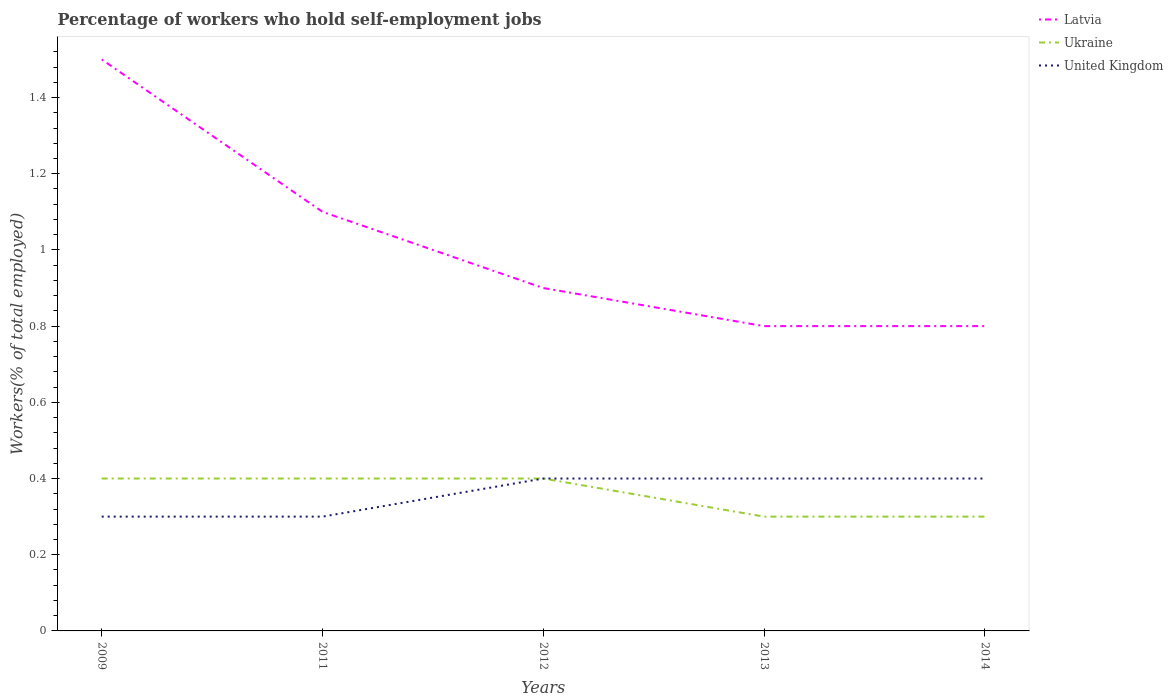How many different coloured lines are there?
Give a very brief answer. 3. Does the line corresponding to Latvia intersect with the line corresponding to Ukraine?
Make the answer very short. No. Is the number of lines equal to the number of legend labels?
Your answer should be very brief. Yes. Across all years, what is the maximum percentage of self-employed workers in United Kingdom?
Offer a very short reply. 0.3. In which year was the percentage of self-employed workers in United Kingdom maximum?
Offer a very short reply. 2009. What is the total percentage of self-employed workers in Ukraine in the graph?
Provide a succinct answer. 0. What is the difference between the highest and the second highest percentage of self-employed workers in Ukraine?
Ensure brevity in your answer.  0.1. Is the percentage of self-employed workers in United Kingdom strictly greater than the percentage of self-employed workers in Ukraine over the years?
Provide a short and direct response. No. How many lines are there?
Your answer should be compact. 3. Does the graph contain any zero values?
Your answer should be very brief. No. How many legend labels are there?
Your answer should be compact. 3. What is the title of the graph?
Offer a terse response. Percentage of workers who hold self-employment jobs. Does "Belarus" appear as one of the legend labels in the graph?
Make the answer very short. No. What is the label or title of the X-axis?
Give a very brief answer. Years. What is the label or title of the Y-axis?
Keep it short and to the point. Workers(% of total employed). What is the Workers(% of total employed) of Latvia in 2009?
Your answer should be compact. 1.5. What is the Workers(% of total employed) of Ukraine in 2009?
Provide a short and direct response. 0.4. What is the Workers(% of total employed) in United Kingdom in 2009?
Your response must be concise. 0.3. What is the Workers(% of total employed) in Latvia in 2011?
Offer a terse response. 1.1. What is the Workers(% of total employed) of Ukraine in 2011?
Offer a very short reply. 0.4. What is the Workers(% of total employed) of United Kingdom in 2011?
Give a very brief answer. 0.3. What is the Workers(% of total employed) in Latvia in 2012?
Offer a very short reply. 0.9. What is the Workers(% of total employed) of Ukraine in 2012?
Your answer should be compact. 0.4. What is the Workers(% of total employed) in United Kingdom in 2012?
Ensure brevity in your answer.  0.4. What is the Workers(% of total employed) in Latvia in 2013?
Your response must be concise. 0.8. What is the Workers(% of total employed) of Ukraine in 2013?
Provide a short and direct response. 0.3. What is the Workers(% of total employed) of United Kingdom in 2013?
Make the answer very short. 0.4. What is the Workers(% of total employed) of Latvia in 2014?
Offer a terse response. 0.8. What is the Workers(% of total employed) of Ukraine in 2014?
Make the answer very short. 0.3. What is the Workers(% of total employed) of United Kingdom in 2014?
Your answer should be very brief. 0.4. Across all years, what is the maximum Workers(% of total employed) in Ukraine?
Ensure brevity in your answer.  0.4. Across all years, what is the maximum Workers(% of total employed) of United Kingdom?
Provide a succinct answer. 0.4. Across all years, what is the minimum Workers(% of total employed) in Latvia?
Make the answer very short. 0.8. Across all years, what is the minimum Workers(% of total employed) in Ukraine?
Provide a succinct answer. 0.3. Across all years, what is the minimum Workers(% of total employed) of United Kingdom?
Give a very brief answer. 0.3. What is the total Workers(% of total employed) in Ukraine in the graph?
Your answer should be compact. 1.8. What is the difference between the Workers(% of total employed) of Latvia in 2009 and that in 2011?
Ensure brevity in your answer.  0.4. What is the difference between the Workers(% of total employed) in Latvia in 2009 and that in 2012?
Provide a short and direct response. 0.6. What is the difference between the Workers(% of total employed) of United Kingdom in 2009 and that in 2012?
Offer a terse response. -0.1. What is the difference between the Workers(% of total employed) of Latvia in 2011 and that in 2012?
Make the answer very short. 0.2. What is the difference between the Workers(% of total employed) of Ukraine in 2011 and that in 2012?
Provide a short and direct response. 0. What is the difference between the Workers(% of total employed) of United Kingdom in 2011 and that in 2012?
Ensure brevity in your answer.  -0.1. What is the difference between the Workers(% of total employed) of Ukraine in 2011 and that in 2013?
Your response must be concise. 0.1. What is the difference between the Workers(% of total employed) in United Kingdom in 2011 and that in 2014?
Your answer should be very brief. -0.1. What is the difference between the Workers(% of total employed) in Latvia in 2012 and that in 2013?
Ensure brevity in your answer.  0.1. What is the difference between the Workers(% of total employed) in Ukraine in 2012 and that in 2013?
Provide a short and direct response. 0.1. What is the difference between the Workers(% of total employed) of Latvia in 2012 and that in 2014?
Ensure brevity in your answer.  0.1. What is the difference between the Workers(% of total employed) of Ukraine in 2012 and that in 2014?
Provide a short and direct response. 0.1. What is the difference between the Workers(% of total employed) of Latvia in 2009 and the Workers(% of total employed) of Ukraine in 2011?
Your answer should be very brief. 1.1. What is the difference between the Workers(% of total employed) in Latvia in 2009 and the Workers(% of total employed) in Ukraine in 2012?
Your answer should be compact. 1.1. What is the difference between the Workers(% of total employed) of Latvia in 2009 and the Workers(% of total employed) of United Kingdom in 2012?
Offer a terse response. 1.1. What is the difference between the Workers(% of total employed) in Latvia in 2009 and the Workers(% of total employed) in Ukraine in 2013?
Keep it short and to the point. 1.2. What is the difference between the Workers(% of total employed) in Ukraine in 2009 and the Workers(% of total employed) in United Kingdom in 2013?
Ensure brevity in your answer.  0. What is the difference between the Workers(% of total employed) in Latvia in 2009 and the Workers(% of total employed) in Ukraine in 2014?
Provide a succinct answer. 1.2. What is the difference between the Workers(% of total employed) of Latvia in 2009 and the Workers(% of total employed) of United Kingdom in 2014?
Offer a very short reply. 1.1. What is the difference between the Workers(% of total employed) of Latvia in 2011 and the Workers(% of total employed) of Ukraine in 2012?
Your response must be concise. 0.7. What is the difference between the Workers(% of total employed) of Latvia in 2011 and the Workers(% of total employed) of United Kingdom in 2012?
Make the answer very short. 0.7. What is the difference between the Workers(% of total employed) in Ukraine in 2011 and the Workers(% of total employed) in United Kingdom in 2012?
Your answer should be very brief. 0. What is the difference between the Workers(% of total employed) in Latvia in 2011 and the Workers(% of total employed) in Ukraine in 2013?
Ensure brevity in your answer.  0.8. What is the difference between the Workers(% of total employed) of Ukraine in 2011 and the Workers(% of total employed) of United Kingdom in 2013?
Your answer should be very brief. 0. What is the difference between the Workers(% of total employed) in Latvia in 2011 and the Workers(% of total employed) in Ukraine in 2014?
Make the answer very short. 0.8. What is the difference between the Workers(% of total employed) in Latvia in 2011 and the Workers(% of total employed) in United Kingdom in 2014?
Provide a short and direct response. 0.7. What is the difference between the Workers(% of total employed) in Ukraine in 2011 and the Workers(% of total employed) in United Kingdom in 2014?
Your answer should be compact. 0. What is the difference between the Workers(% of total employed) in Ukraine in 2012 and the Workers(% of total employed) in United Kingdom in 2013?
Give a very brief answer. 0. What is the difference between the Workers(% of total employed) in Latvia in 2012 and the Workers(% of total employed) in United Kingdom in 2014?
Your response must be concise. 0.5. What is the difference between the Workers(% of total employed) in Latvia in 2013 and the Workers(% of total employed) in United Kingdom in 2014?
Make the answer very short. 0.4. What is the average Workers(% of total employed) in Ukraine per year?
Your answer should be compact. 0.36. What is the average Workers(% of total employed) of United Kingdom per year?
Your response must be concise. 0.36. In the year 2009, what is the difference between the Workers(% of total employed) of Latvia and Workers(% of total employed) of United Kingdom?
Keep it short and to the point. 1.2. In the year 2009, what is the difference between the Workers(% of total employed) of Ukraine and Workers(% of total employed) of United Kingdom?
Keep it short and to the point. 0.1. In the year 2011, what is the difference between the Workers(% of total employed) in Latvia and Workers(% of total employed) in Ukraine?
Your answer should be compact. 0.7. In the year 2011, what is the difference between the Workers(% of total employed) in Ukraine and Workers(% of total employed) in United Kingdom?
Your answer should be compact. 0.1. In the year 2012, what is the difference between the Workers(% of total employed) in Latvia and Workers(% of total employed) in Ukraine?
Ensure brevity in your answer.  0.5. In the year 2013, what is the difference between the Workers(% of total employed) in Latvia and Workers(% of total employed) in Ukraine?
Give a very brief answer. 0.5. In the year 2013, what is the difference between the Workers(% of total employed) of Latvia and Workers(% of total employed) of United Kingdom?
Your response must be concise. 0.4. In the year 2013, what is the difference between the Workers(% of total employed) of Ukraine and Workers(% of total employed) of United Kingdom?
Offer a terse response. -0.1. In the year 2014, what is the difference between the Workers(% of total employed) of Latvia and Workers(% of total employed) of Ukraine?
Offer a terse response. 0.5. In the year 2014, what is the difference between the Workers(% of total employed) of Ukraine and Workers(% of total employed) of United Kingdom?
Keep it short and to the point. -0.1. What is the ratio of the Workers(% of total employed) in Latvia in 2009 to that in 2011?
Your answer should be very brief. 1.36. What is the ratio of the Workers(% of total employed) of Ukraine in 2009 to that in 2011?
Ensure brevity in your answer.  1. What is the ratio of the Workers(% of total employed) of Ukraine in 2009 to that in 2012?
Make the answer very short. 1. What is the ratio of the Workers(% of total employed) of Latvia in 2009 to that in 2013?
Keep it short and to the point. 1.88. What is the ratio of the Workers(% of total employed) in United Kingdom in 2009 to that in 2013?
Offer a very short reply. 0.75. What is the ratio of the Workers(% of total employed) of Latvia in 2009 to that in 2014?
Your response must be concise. 1.88. What is the ratio of the Workers(% of total employed) of United Kingdom in 2009 to that in 2014?
Make the answer very short. 0.75. What is the ratio of the Workers(% of total employed) in Latvia in 2011 to that in 2012?
Your answer should be very brief. 1.22. What is the ratio of the Workers(% of total employed) in Ukraine in 2011 to that in 2012?
Give a very brief answer. 1. What is the ratio of the Workers(% of total employed) in United Kingdom in 2011 to that in 2012?
Provide a short and direct response. 0.75. What is the ratio of the Workers(% of total employed) in Latvia in 2011 to that in 2013?
Your response must be concise. 1.38. What is the ratio of the Workers(% of total employed) of Latvia in 2011 to that in 2014?
Provide a succinct answer. 1.38. What is the ratio of the Workers(% of total employed) in Ukraine in 2011 to that in 2014?
Keep it short and to the point. 1.33. What is the ratio of the Workers(% of total employed) of Latvia in 2012 to that in 2013?
Offer a terse response. 1.12. What is the ratio of the Workers(% of total employed) in Ukraine in 2012 to that in 2013?
Make the answer very short. 1.33. What is the ratio of the Workers(% of total employed) of Latvia in 2012 to that in 2014?
Offer a terse response. 1.12. What is the ratio of the Workers(% of total employed) of Ukraine in 2012 to that in 2014?
Your answer should be very brief. 1.33. What is the ratio of the Workers(% of total employed) of United Kingdom in 2012 to that in 2014?
Keep it short and to the point. 1. What is the ratio of the Workers(% of total employed) in Latvia in 2013 to that in 2014?
Your answer should be very brief. 1. What is the ratio of the Workers(% of total employed) in Ukraine in 2013 to that in 2014?
Give a very brief answer. 1. What is the difference between the highest and the second highest Workers(% of total employed) in Latvia?
Make the answer very short. 0.4. What is the difference between the highest and the second highest Workers(% of total employed) of United Kingdom?
Make the answer very short. 0. What is the difference between the highest and the lowest Workers(% of total employed) of Ukraine?
Give a very brief answer. 0.1. What is the difference between the highest and the lowest Workers(% of total employed) in United Kingdom?
Offer a terse response. 0.1. 